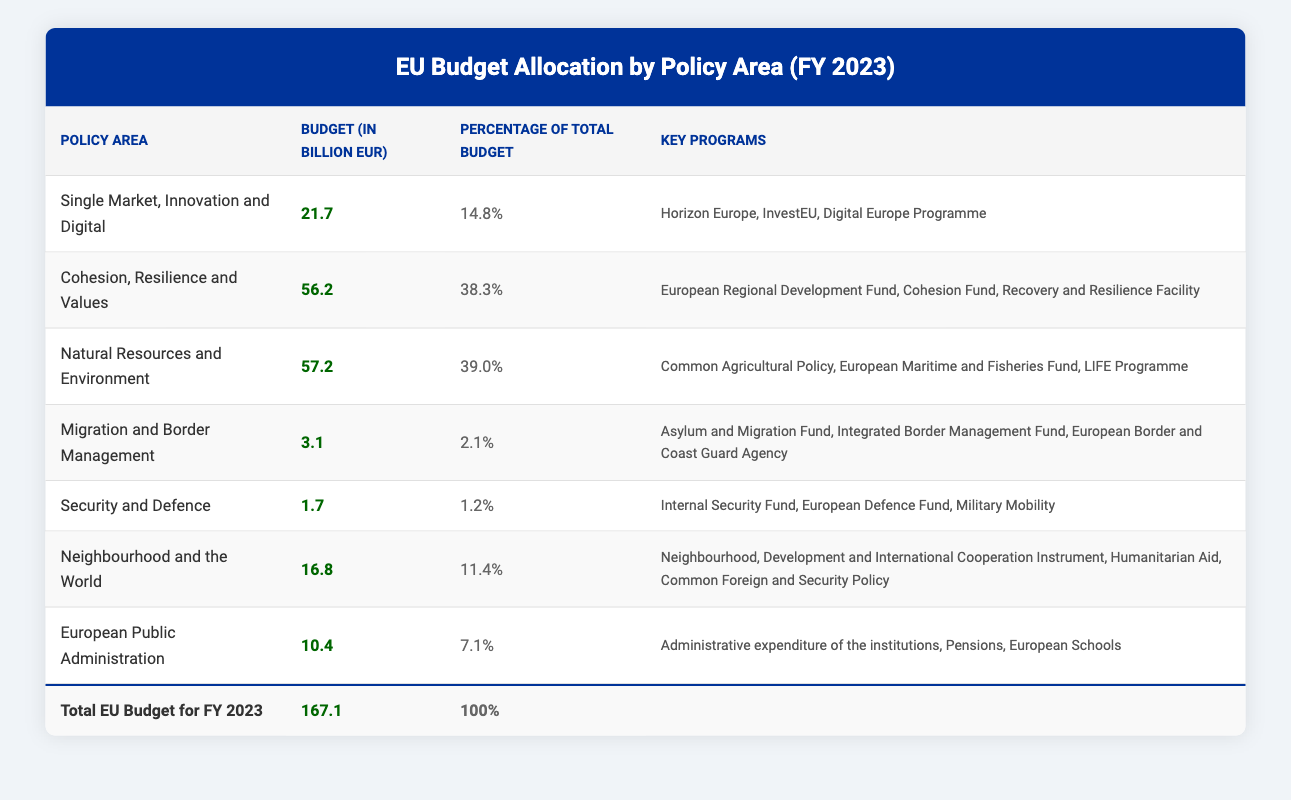What is the budget allocated to the policy area of Natural Resources and Environment? The table specifies that the budget allocated to the policy area of Natural Resources and Environment is 57.2 billion EUR.
Answer: 57.2 billion EUR What percentage of the total EU budget is allocated to Security and Defence? According to the table, the percentage of the total EU budget allocated to Security and Defence is 1.2%.
Answer: 1.2% Which policy area has the highest budget allocation? By reviewing the table, we can see that the policy area with the highest budget allocation is Natural Resources and Environment with 57.2 billion EUR.
Answer: Natural Resources and Environment What is the sum of the budgets allocated to Migration and Border Management and Security and Defence? Adding the budgets for these two areas: 3.1 billion EUR (Migration and Border Management) + 1.7 billion EUR (Security and Defence) = 4.8 billion EUR.
Answer: 4.8 billion EUR Is it true that the Cohesion, Resilience and Values policy area has a budget allocation that is higher than 50 billion EUR? The budget for the Cohesion, Resilience and Values policy area is 56.2 billion EUR, which is indeed higher than 50 billion EUR, making this statement true.
Answer: True If we exclude the budget allocated to the policy area of Single Market, Innovation and Digital, what percentage of the total budget is allocated to the remaining policy areas? The budget for Single Market, Innovation and Digital is 21.7 billion EUR. Therefore, the budget for the remaining areas is 167.1 billion EUR (total) - 21.7 billion EUR = 145.4 billion EUR. The percentage for the remaining areas is (145.4 billion EUR / 167.1 billion EUR) * 100% ≈ 87%.
Answer: Approximately 87% How many key programs are listed under the Neighbourhood and the World policy area? The table shows that there are three key programs listed under the Neighbourhood and the World policy area, which are Neighbourhood, Development and International Cooperation Instrument, Humanitarian Aid, and Common Foreign and Security Policy.
Answer: 3 key programs What is the average budget allocation across all policy areas? The total budget is 167.1 billion EUR and there are 7 policy areas. Hence, the average allocation is 167.1 billion EUR / 7 ≈ 23.9 billion EUR.
Answer: Approximately 23.9 billion EUR Is the budget allocation for the Migration and Border Management policy area less than 5 billion EUR? The budget for Migration and Border Management is 3.1 billion EUR, which is less than 5 billion EUR, confirming that this statement is true.
Answer: True 